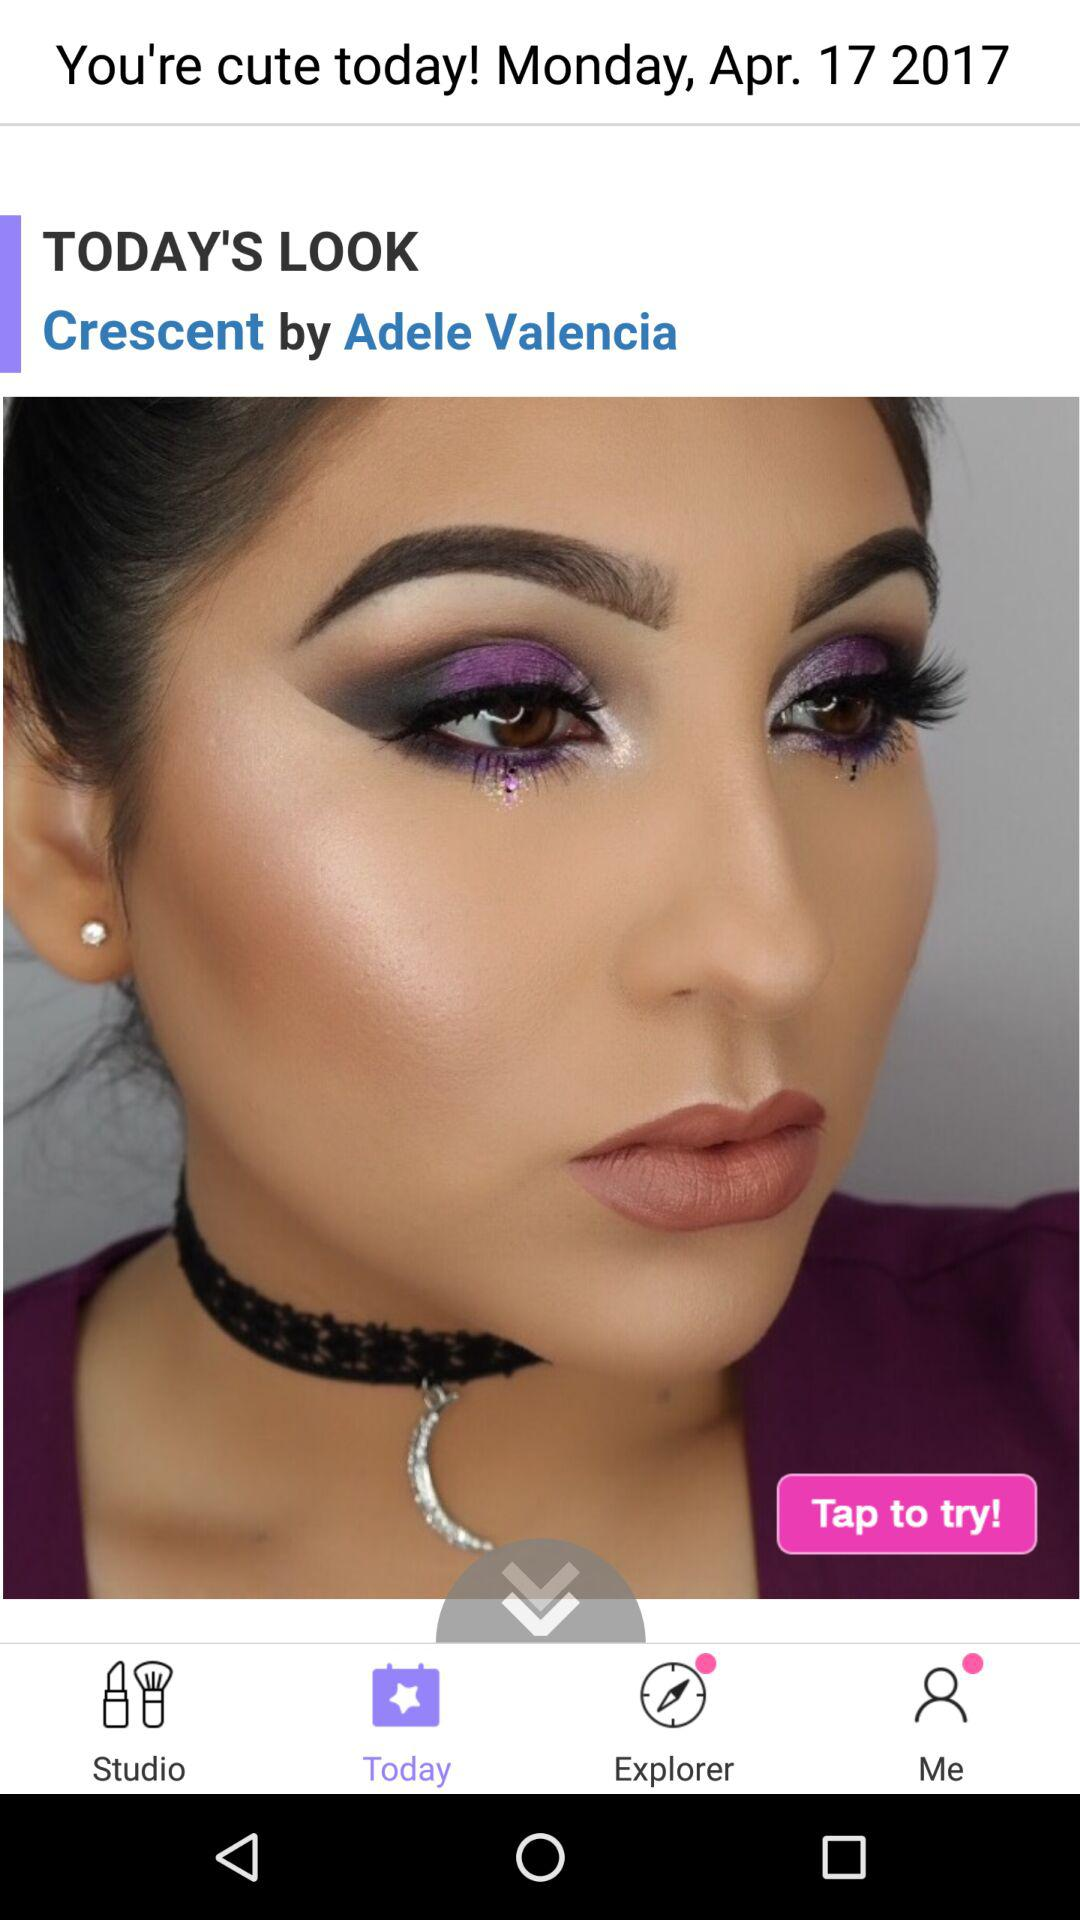"Today's Look Crescent" done by whom? "Today's Look Crescent" is done by Adele Valencia. 